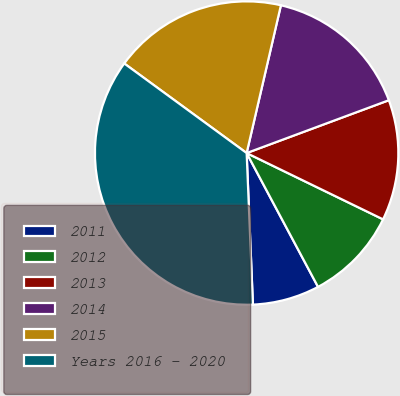Convert chart to OTSL. <chart><loc_0><loc_0><loc_500><loc_500><pie_chart><fcel>2011<fcel>2012<fcel>2013<fcel>2014<fcel>2015<fcel>Years 2016 - 2020<nl><fcel>7.14%<fcel>10.0%<fcel>12.86%<fcel>15.71%<fcel>18.57%<fcel>35.71%<nl></chart> 